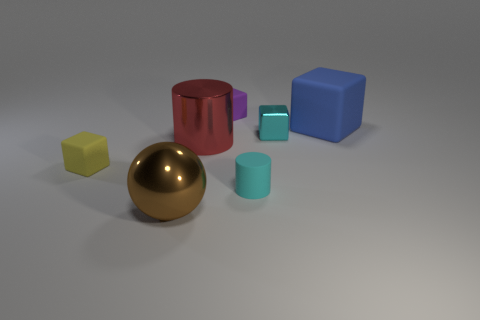What number of other things are there of the same size as the red metal cylinder?
Your answer should be very brief. 2. Are there any cyan rubber balls that have the same size as the rubber cylinder?
Your answer should be very brief. No. Does the small rubber cube that is in front of the purple cube have the same color as the shiny cube?
Make the answer very short. No. How many objects are either balls or large gray balls?
Offer a very short reply. 1. Does the thing that is to the left of the brown sphere have the same size as the metallic ball?
Your response must be concise. No. What is the size of the object that is left of the small cyan block and behind the red thing?
Make the answer very short. Small. How many other things are there of the same shape as the small yellow matte object?
Ensure brevity in your answer.  3. What number of other things are there of the same material as the small cyan block
Ensure brevity in your answer.  2. What size is the purple thing that is the same shape as the blue rubber object?
Make the answer very short. Small. Do the big cylinder and the metallic cube have the same color?
Ensure brevity in your answer.  No. 